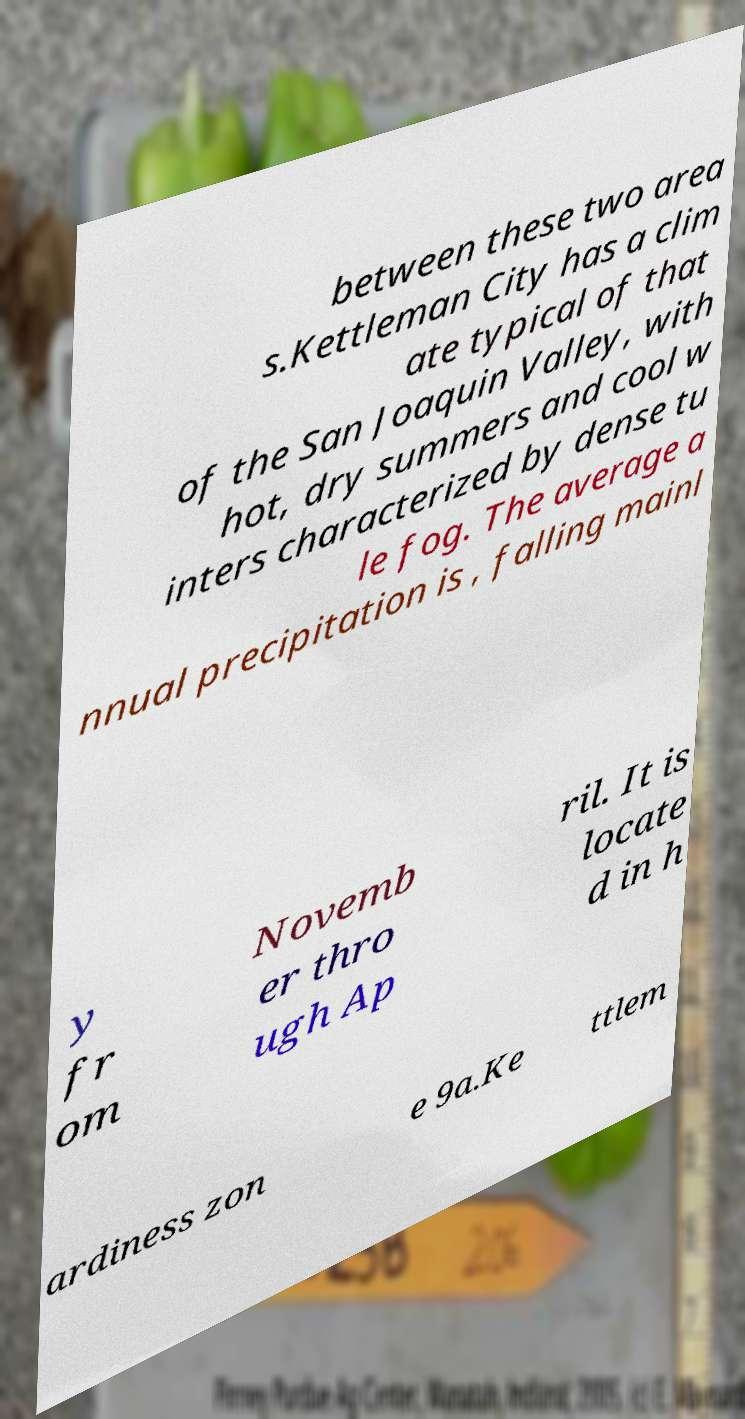Can you accurately transcribe the text from the provided image for me? between these two area s.Kettleman City has a clim ate typical of that of the San Joaquin Valley, with hot, dry summers and cool w inters characterized by dense tu le fog. The average a nnual precipitation is , falling mainl y fr om Novemb er thro ugh Ap ril. It is locate d in h ardiness zon e 9a.Ke ttlem 